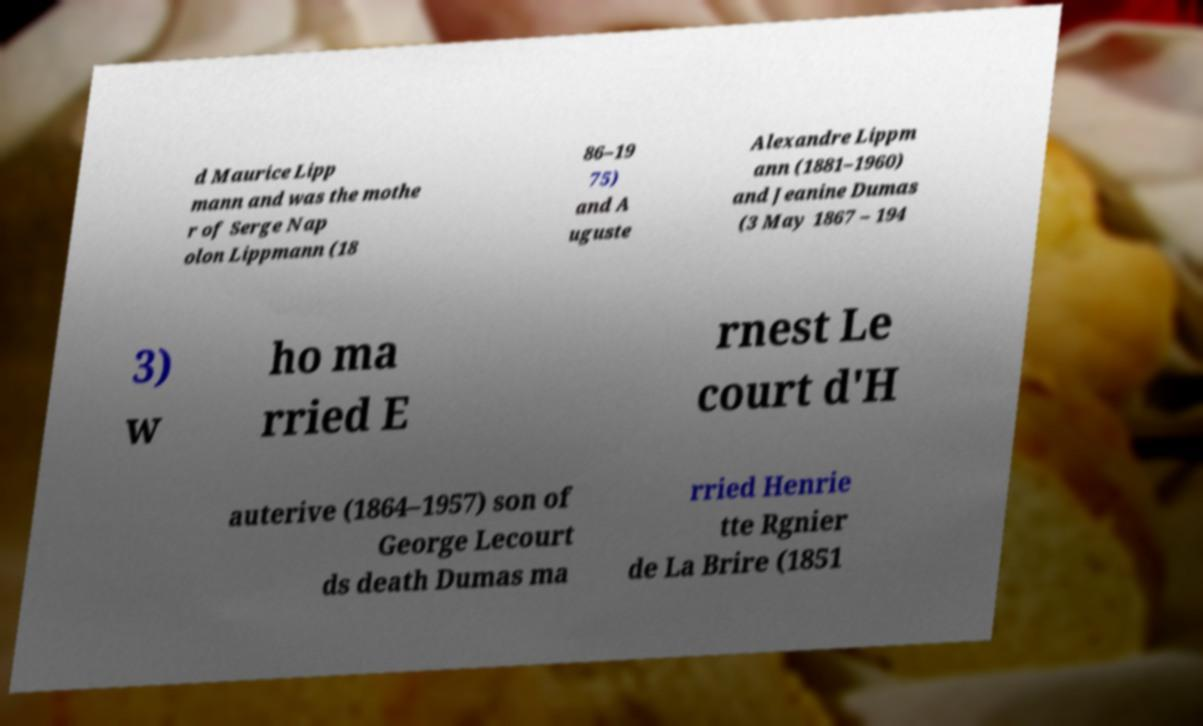There's text embedded in this image that I need extracted. Can you transcribe it verbatim? d Maurice Lipp mann and was the mothe r of Serge Nap olon Lippmann (18 86–19 75) and A uguste Alexandre Lippm ann (1881–1960) and Jeanine Dumas (3 May 1867 – 194 3) w ho ma rried E rnest Le court d'H auterive (1864–1957) son of George Lecourt ds death Dumas ma rried Henrie tte Rgnier de La Brire (1851 